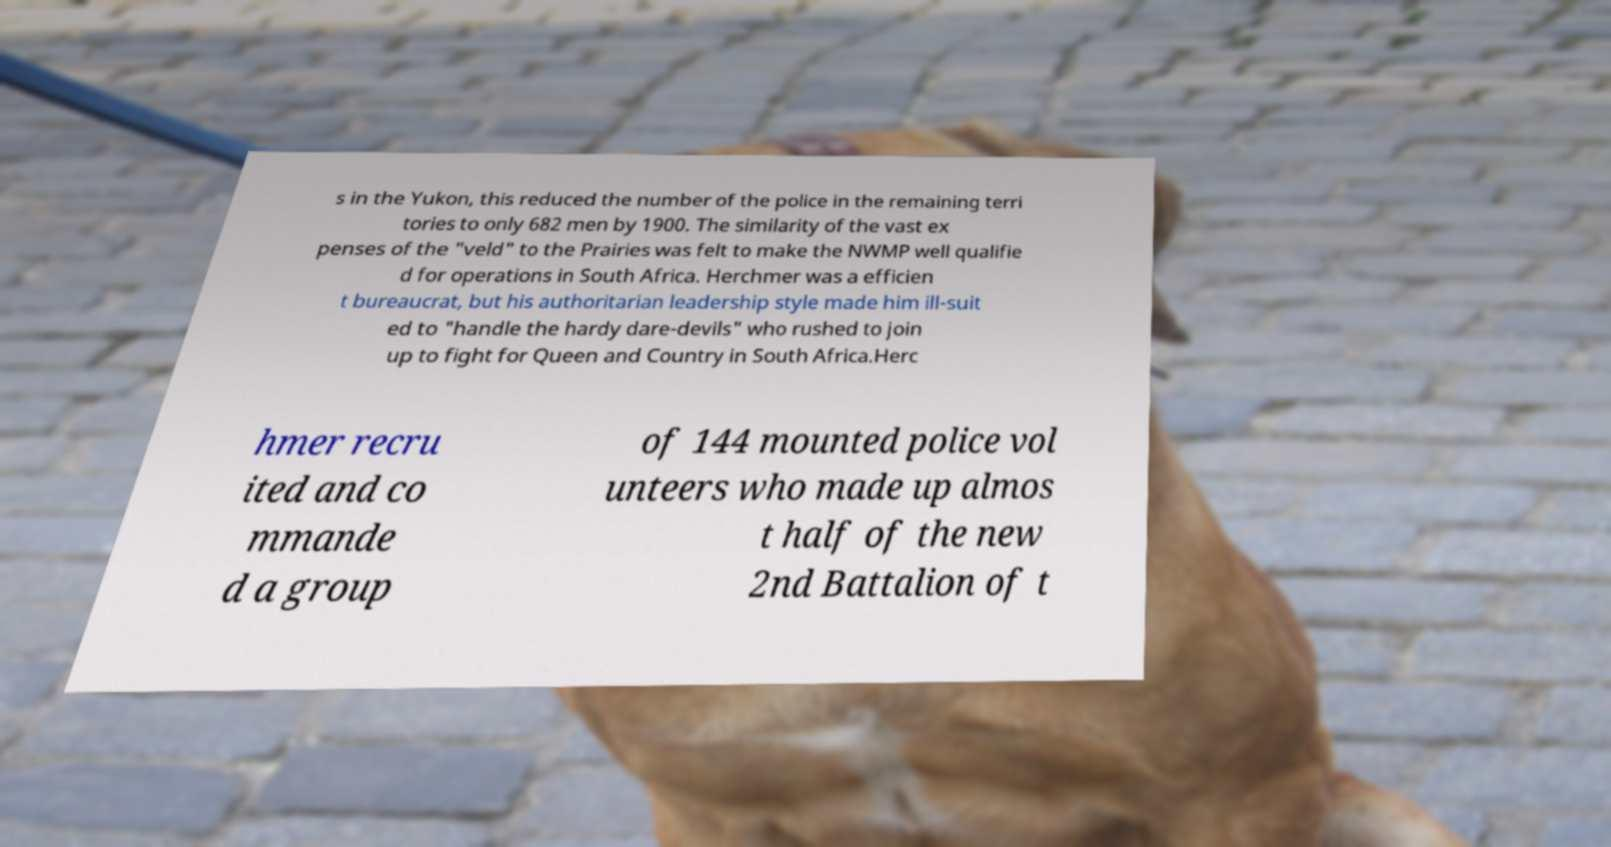Please read and relay the text visible in this image. What does it say? s in the Yukon, this reduced the number of the police in the remaining terri tories to only 682 men by 1900. The similarity of the vast ex penses of the "veld" to the Prairies was felt to make the NWMP well qualifie d for operations in South Africa. Herchmer was a efficien t bureaucrat, but his authoritarian leadership style made him ill-suit ed to "handle the hardy dare-devils" who rushed to join up to fight for Queen and Country in South Africa.Herc hmer recru ited and co mmande d a group of 144 mounted police vol unteers who made up almos t half of the new 2nd Battalion of t 